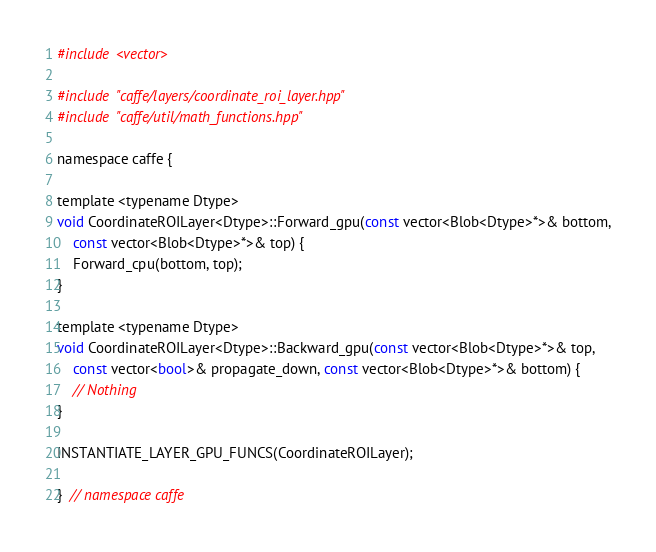Convert code to text. <code><loc_0><loc_0><loc_500><loc_500><_Cuda_>#include <vector>

#include "caffe/layers/coordinate_roi_layer.hpp"
#include "caffe/util/math_functions.hpp"

namespace caffe {

template <typename Dtype>
void CoordinateROILayer<Dtype>::Forward_gpu(const vector<Blob<Dtype>*>& bottom,
    const vector<Blob<Dtype>*>& top) {
    Forward_cpu(bottom, top);
}

template <typename Dtype>
void CoordinateROILayer<Dtype>::Backward_gpu(const vector<Blob<Dtype>*>& top,
    const vector<bool>& propagate_down, const vector<Blob<Dtype>*>& bottom) {
    // Nothing
}

INSTANTIATE_LAYER_GPU_FUNCS(CoordinateROILayer);

}  // namespace caffe
</code> 